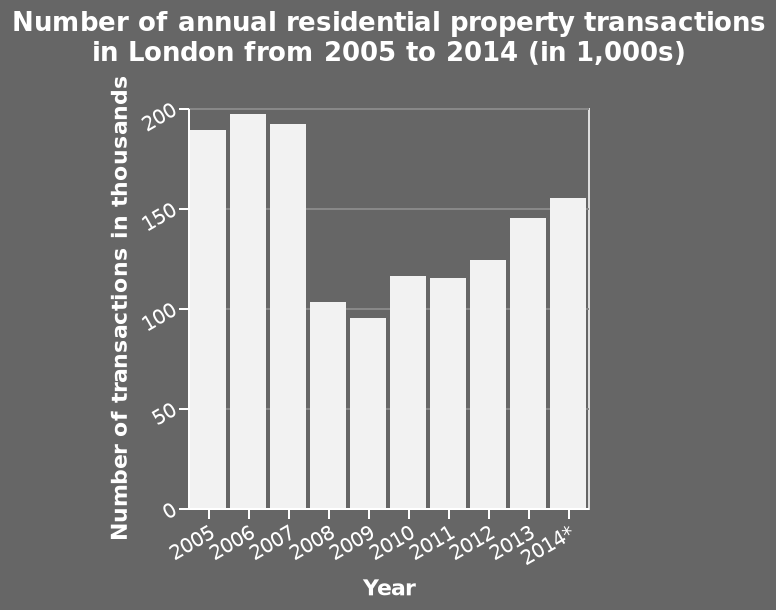<image>
When did the large drop occur?  The large drop occurred in 2008. What does the x-axis represent on the bar chart?  The x-axis on the bar chart represents the years from 2005 to 2014. What is the label on the x-axis for the last point of the bar chart? The label on the x-axis for the last point of the bar chart is "2014*". 